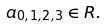<formula> <loc_0><loc_0><loc_500><loc_500>a _ { 0 , 1 , 2 , 3 } \in R .</formula> 